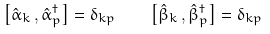Convert formula to latex. <formula><loc_0><loc_0><loc_500><loc_500>\left [ \hat { \alpha } _ { k } \, , \hat { \alpha } _ { p } ^ { \dagger } \right ] = \delta _ { k p } \quad \left [ \hat { \beta } _ { k } \, , \hat { \beta } _ { p } ^ { \dagger } \right ] = \delta _ { k p }</formula> 